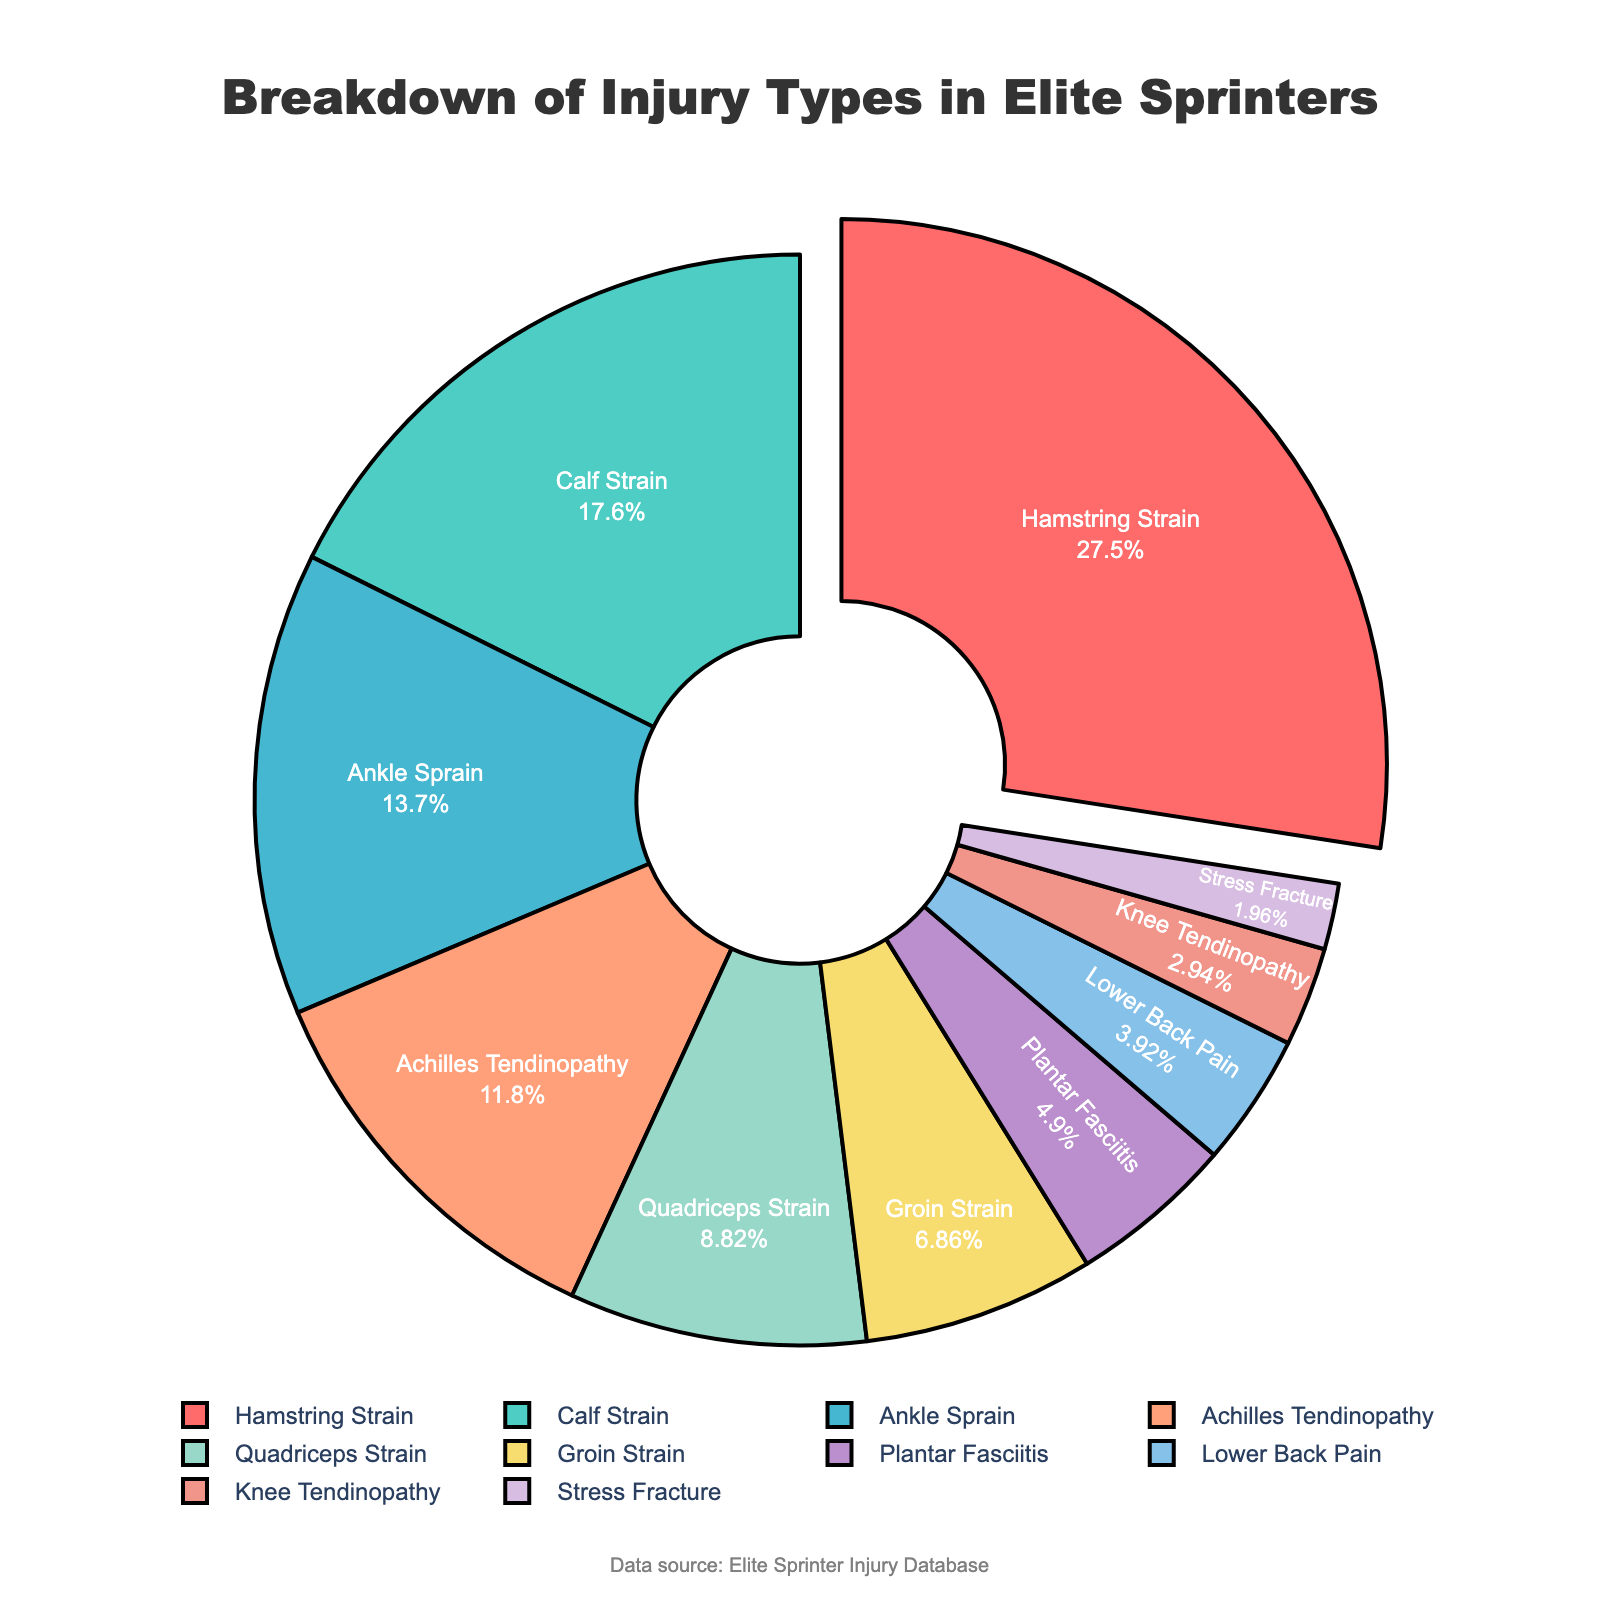What's the most common injury type among elite sprinters? The figure shows the breakdown of injury types with percentages. The most common injury type is the one with the highest percentage, which is Hamstring Strain at 28%.
Answer: Hamstring Strain How much more common are Hamstring Strains compared to Stress Fractures? To find the difference in their percentages, subtract the percentage of Stress Fractures (2%) from that of Hamstring Strains (28%): 28% - 2% = 26%.
Answer: 26% Which injury types collectively make up more than half of the total injuries? Add up the percentages of injuries in descending order until the sum exceeds 50%. Hamstring Strain (28%) + Calf Strain (18%) + Ankle Sprain (14%) = 60%. Thus, these three injury types contribute more than half.
Answer: Hamstring Strain, Calf Strain, Ankle Sprain What percentage of injuries are related to strains (including Hamstring, Calf, Quadriceps, and Groin strains)? Sum the percentages of all types of strains: Hamstring Strain (28%) + Calf Strain (18%) + Quadriceps Strain (9%) + Groin Strain (7%) = 62%.
Answer: 62% Is Lower Back Pain more common than Plantar Fasciitis? Compare the percentages of Lower Back Pain (4%) and Plantar Fasciitis (5%). Lower Back Pain has a lower percentage than Plantar Fasciitis.
Answer: No What is the least common injury type, and what percentage does it represent? The figure shows that the smallest slice represents Stress Fractures at 2%.
Answer: Stress Fracture, 2% Do Ankle Sprains occur more frequently than any type of tendinopathy (Achilles Tendinopathy and Knee Tendinopathy combined)? The percentage of Ankle Sprains is 14%. The combined percentage of Achillles Tendinopathy (12%) and Knee Tendinopathy (3%) is 15%. Thus, Ankle Sprains are less frequent.
Answer: No What percentage of the injuries fall into the category of tendinopathy (Achilles and Knee)? Sum the percentages of Achilles Tendinopathy (12%) and Knee Tendinopathy (3%) to find the total tendinopathy percentage: 12% + 3% = 15%.
Answer: 15% What is the combined percentage of injuries occurring in the lower leg (Calf Strain, Ankle Sprain, Achilles Tendinopathy, and Plantar Fasciitis)? Add the percentages: Calf Strain (18%) + Ankle Sprain (14%) + Achilles Tendinopathy (12%) + Plantar Fasciitis (5%) = 49%.
Answer: 49% 